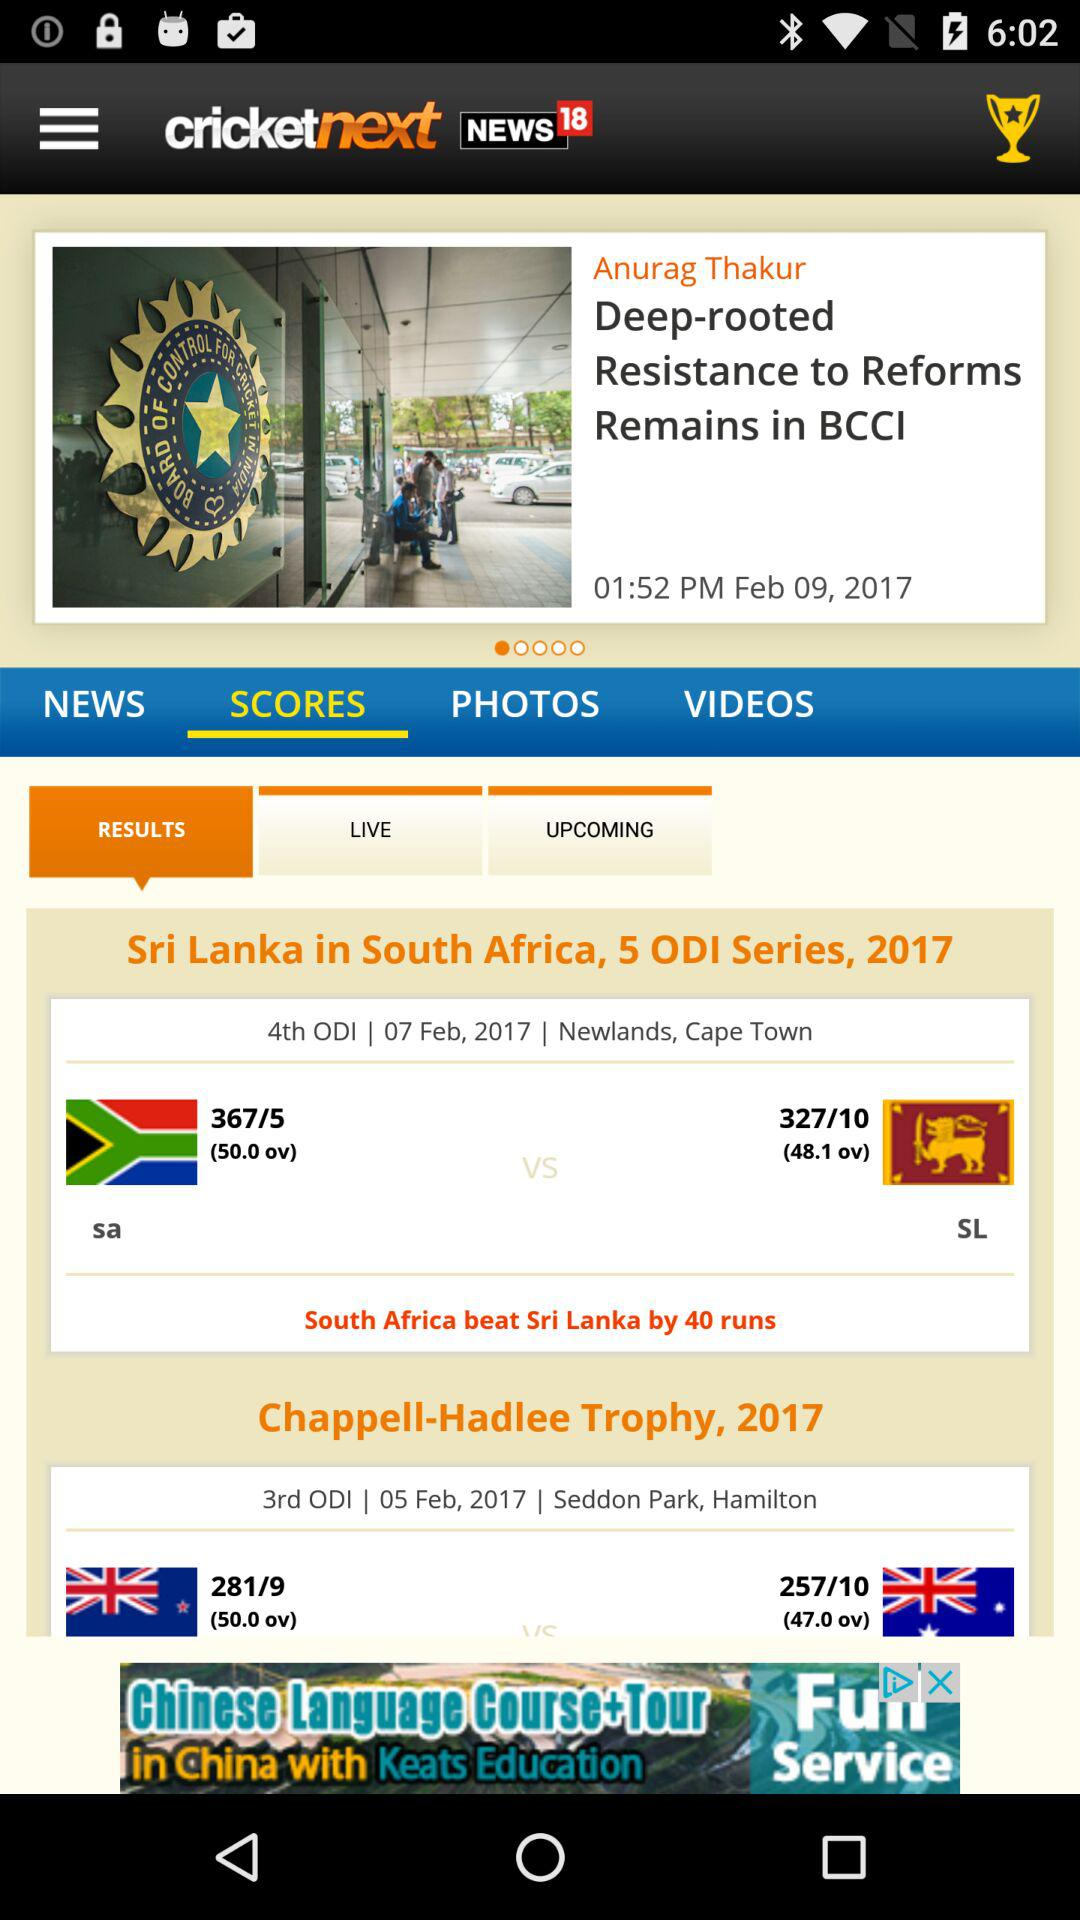Where was the "Chappell-Hadlee Trophy, 2017" played? The "Chappell-Hadlee Trophy, 2017" was played in Seddon Park, Hamilton. 